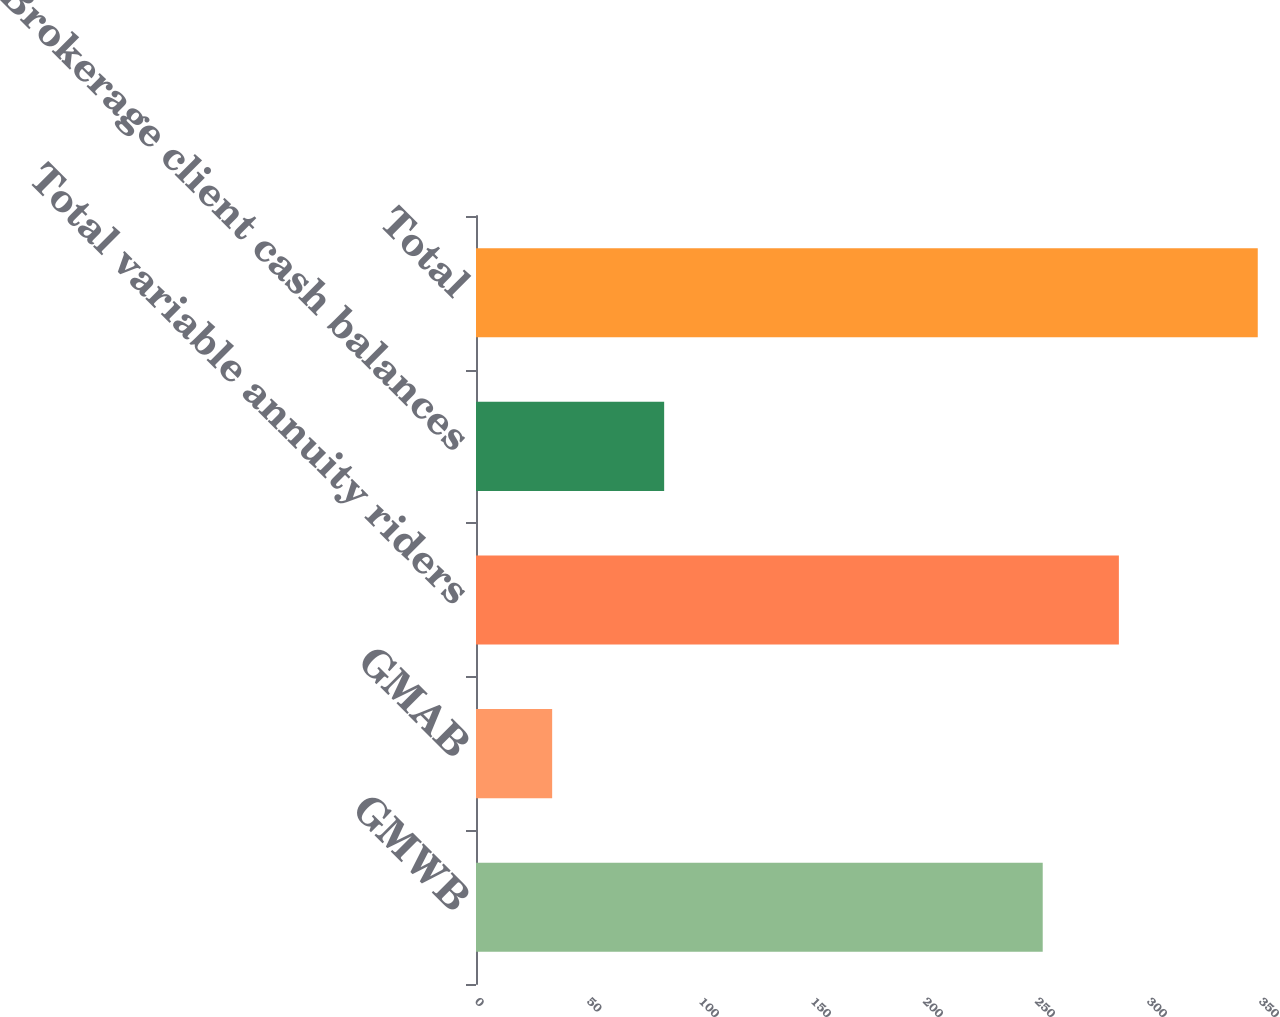<chart> <loc_0><loc_0><loc_500><loc_500><bar_chart><fcel>GMWB<fcel>GMAB<fcel>Total variable annuity riders<fcel>Brokerage client cash balances<fcel>Total<nl><fcel>253<fcel>34<fcel>287<fcel>84<fcel>349<nl></chart> 